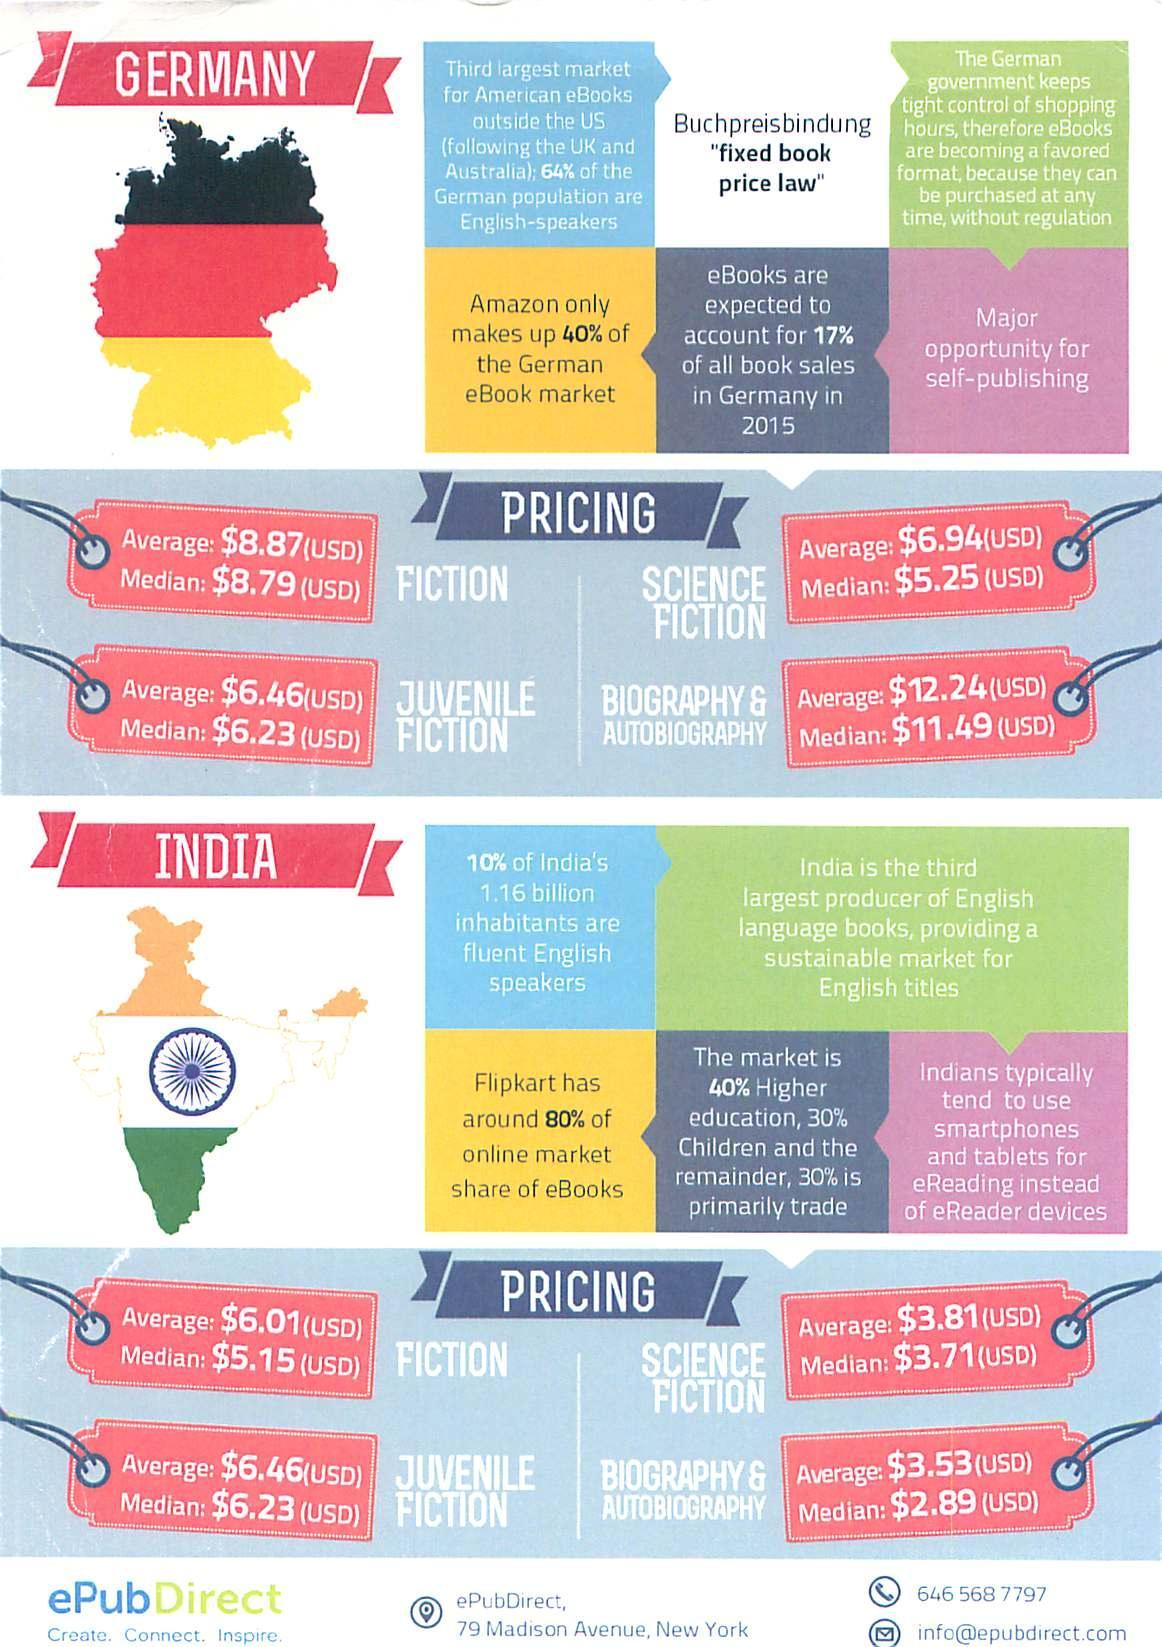What percentage of online market share of eBooks does Flipcart have?
Answer the question with a short phrase. 80% Which is the second largest market for American eBooks outside the US? Australia. 